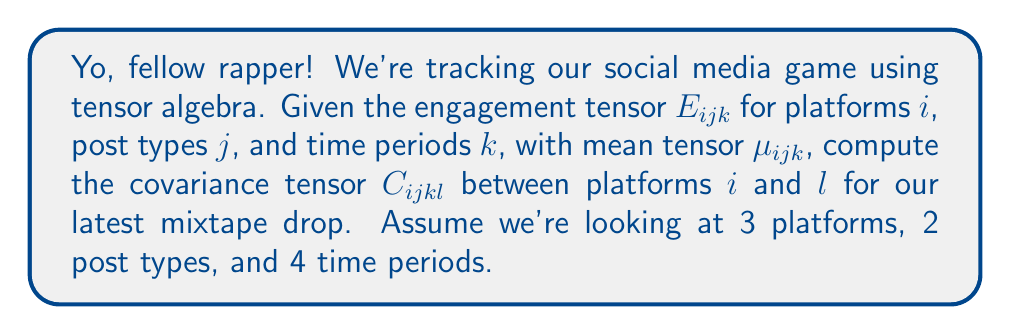Could you help me with this problem? Alright, let's break this down step by step:

1) The covariance tensor $C_{ijkl}$ is defined as:

   $$C_{ijkl} = \mathbb{E}[(E_{ijk} - \mu_{ijk})(E_{ljk} - \mu_{ljk})]$$

2) We need to compute this expectation over all post types $j$ and time periods $k$.

3) Let's expand this:

   $$C_{ijkl} = \frac{1}{2 \cdot 4} \sum_{j=1}^2 \sum_{k=1}^4 (E_{ijk} - \mu_{ijk})(E_{ljk} - \mu_{ljk})$$

4) This results in a 4th-order tensor with dimensions 3x3x2x4, representing covariances between each pair of platforms for each post type and time period.

5) To compute each element:
   - Subtract the mean $\mu_{ijk}$ from each engagement value $E_{ijk}$
   - Multiply the differences for platforms $i$ and $l$
   - Sum over all post types and time periods
   - Divide by the total number of observations (2 * 4 = 8)

6) The result is a symmetric tensor where $C_{ijkl} = C_{lijk}$ for all $i$, $j$, $k$, and $l$.
Answer: $$C_{ijkl} = \frac{1}{8} \sum_{j=1}^2 \sum_{k=1}^4 (E_{ijk} - \mu_{ijk})(E_{ljk} - \mu_{ljk})$$ 